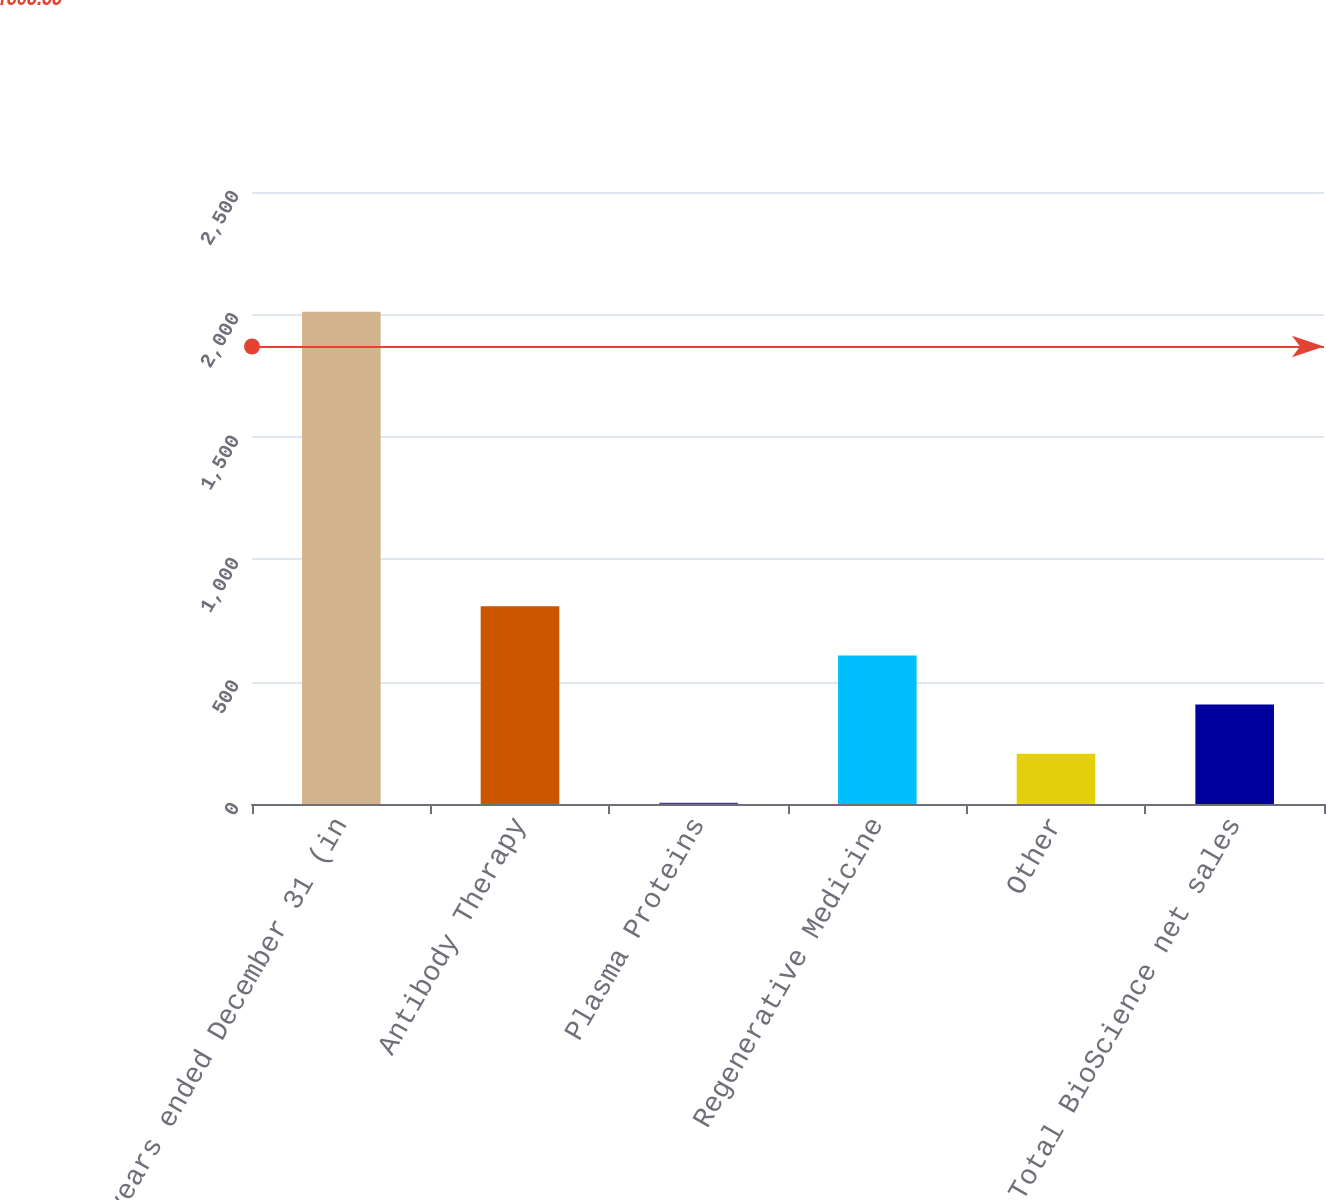Convert chart. <chart><loc_0><loc_0><loc_500><loc_500><bar_chart><fcel>years ended December 31 (in<fcel>Antibody Therapy<fcel>Plasma Proteins<fcel>Regenerative Medicine<fcel>Other<fcel>Total BioScience net sales<nl><fcel>2011<fcel>807.4<fcel>5<fcel>606.8<fcel>205.6<fcel>406.2<nl></chart> 